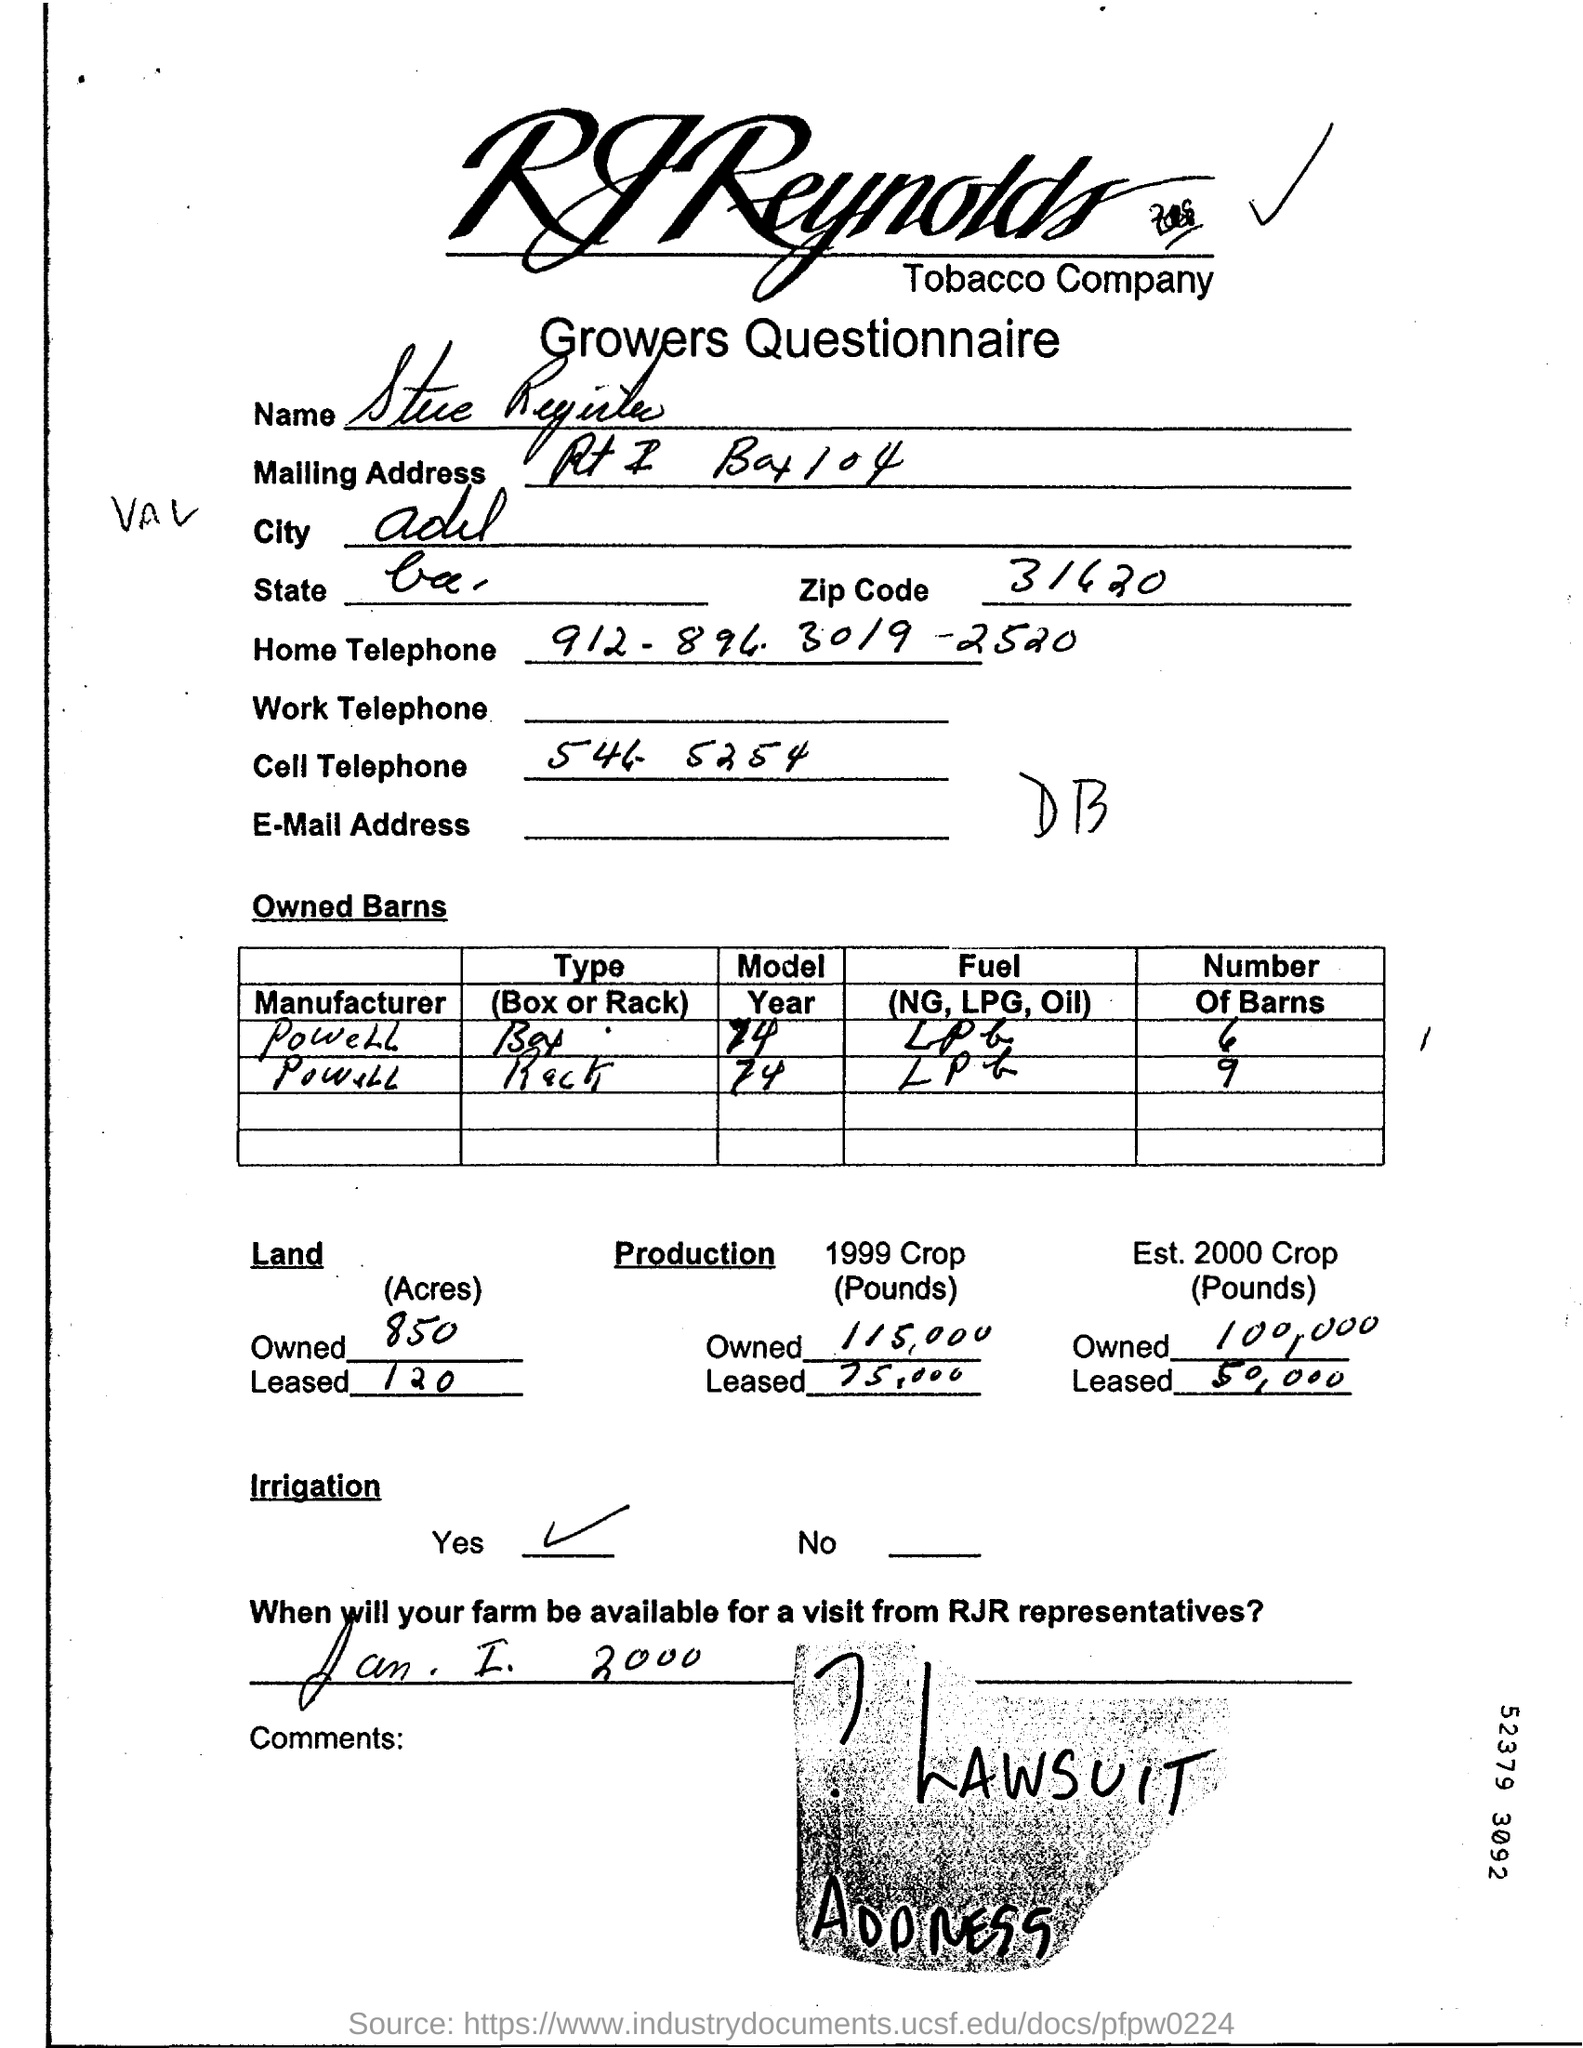What is the Zip Code?
Your answer should be compact. 31620. 